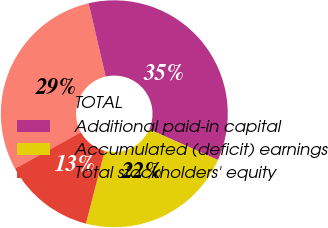Convert chart. <chart><loc_0><loc_0><loc_500><loc_500><pie_chart><fcel>TOTAL<fcel>Additional paid-in capital<fcel>Accumulated (deficit) earnings<fcel>Total stockholders' equity<nl><fcel>29.4%<fcel>35.31%<fcel>22.35%<fcel>12.94%<nl></chart> 